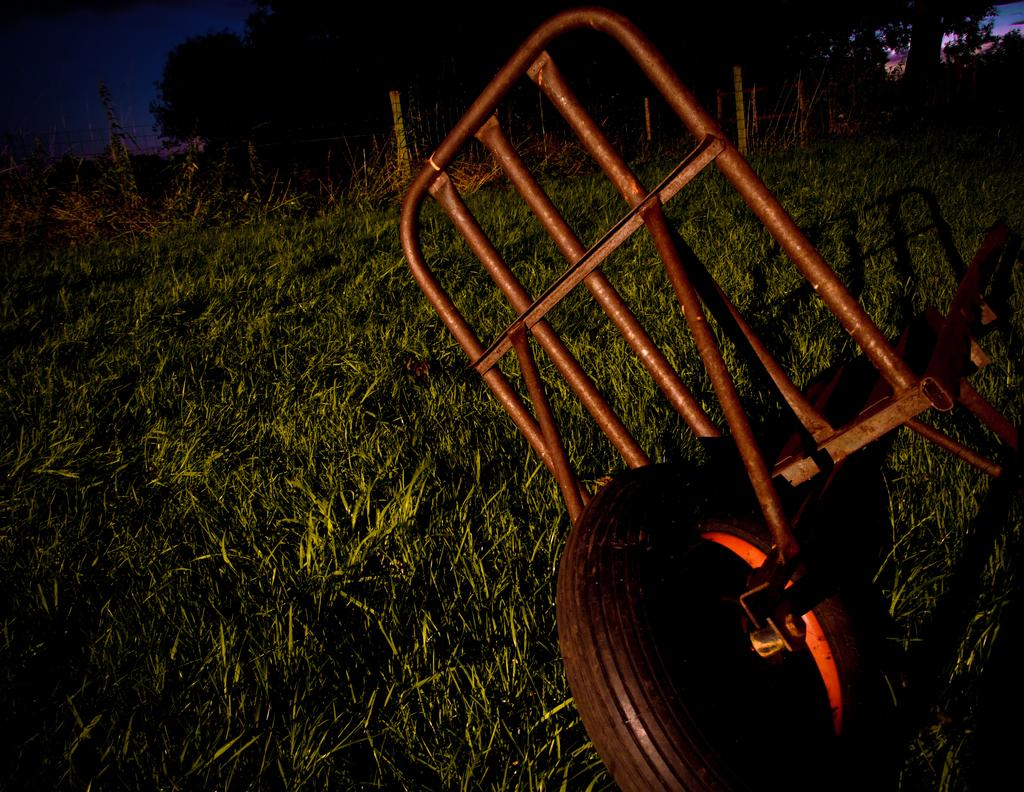What is the main object in the image? There is a grass trolley in the image. Where is the grass trolley located? The grass trolley is on the grass. What can be seen in the background of the image? There are trees and the sky visible in the background of the image. What type of seed is being planted in the grass trolley in the image? There is no seed being planted in the grass trolley in the image; it is just a grass trolley on the grass. Can you recite a verse that is written on the grass trolley in the image? There is no verse written on the grass trolley in the image. 